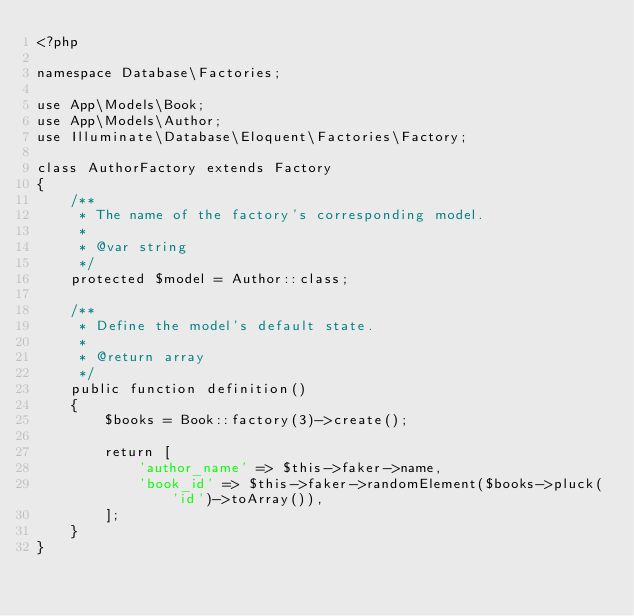<code> <loc_0><loc_0><loc_500><loc_500><_PHP_><?php

namespace Database\Factories;

use App\Models\Book;
use App\Models\Author;
use Illuminate\Database\Eloquent\Factories\Factory;

class AuthorFactory extends Factory
{
    /**
     * The name of the factory's corresponding model.
     *
     * @var string
     */
    protected $model = Author::class;

    /**
     * Define the model's default state.
     *
     * @return array
     */
    public function definition()
    {
        $books = Book::factory(3)->create();
        
        return [
            'author_name' => $this->faker->name,
            'book_id' => $this->faker->randomElement($books->pluck('id')->toArray()),
        ];
    }
}
</code> 